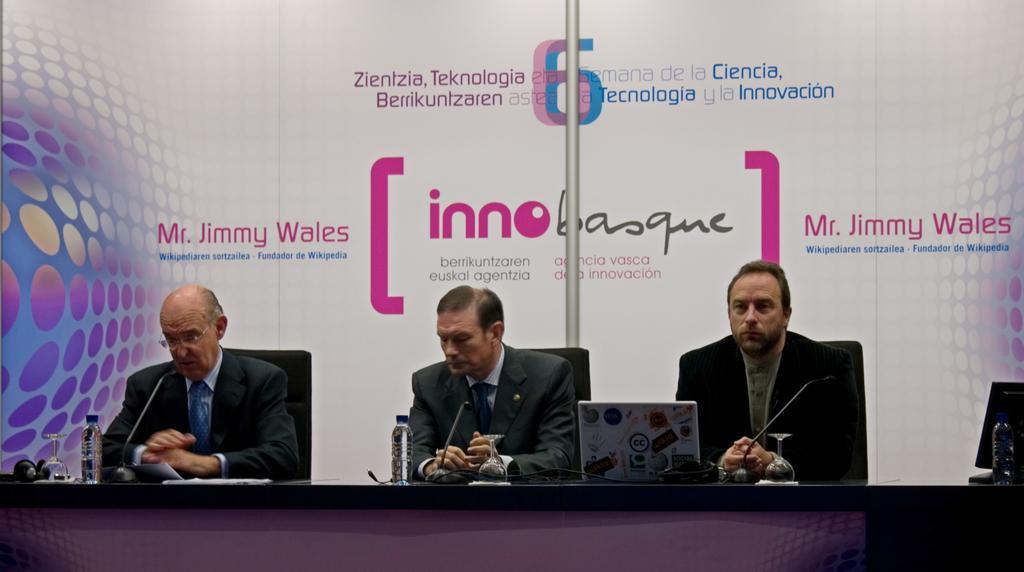Can you describe this image briefly? In this image I can see three people are siting in-front of the table and these people are wearing the blazers. I can see there is a laptop, mic, glass and bottles on the table. In the back there is a white color banner and there are many names written on it. 